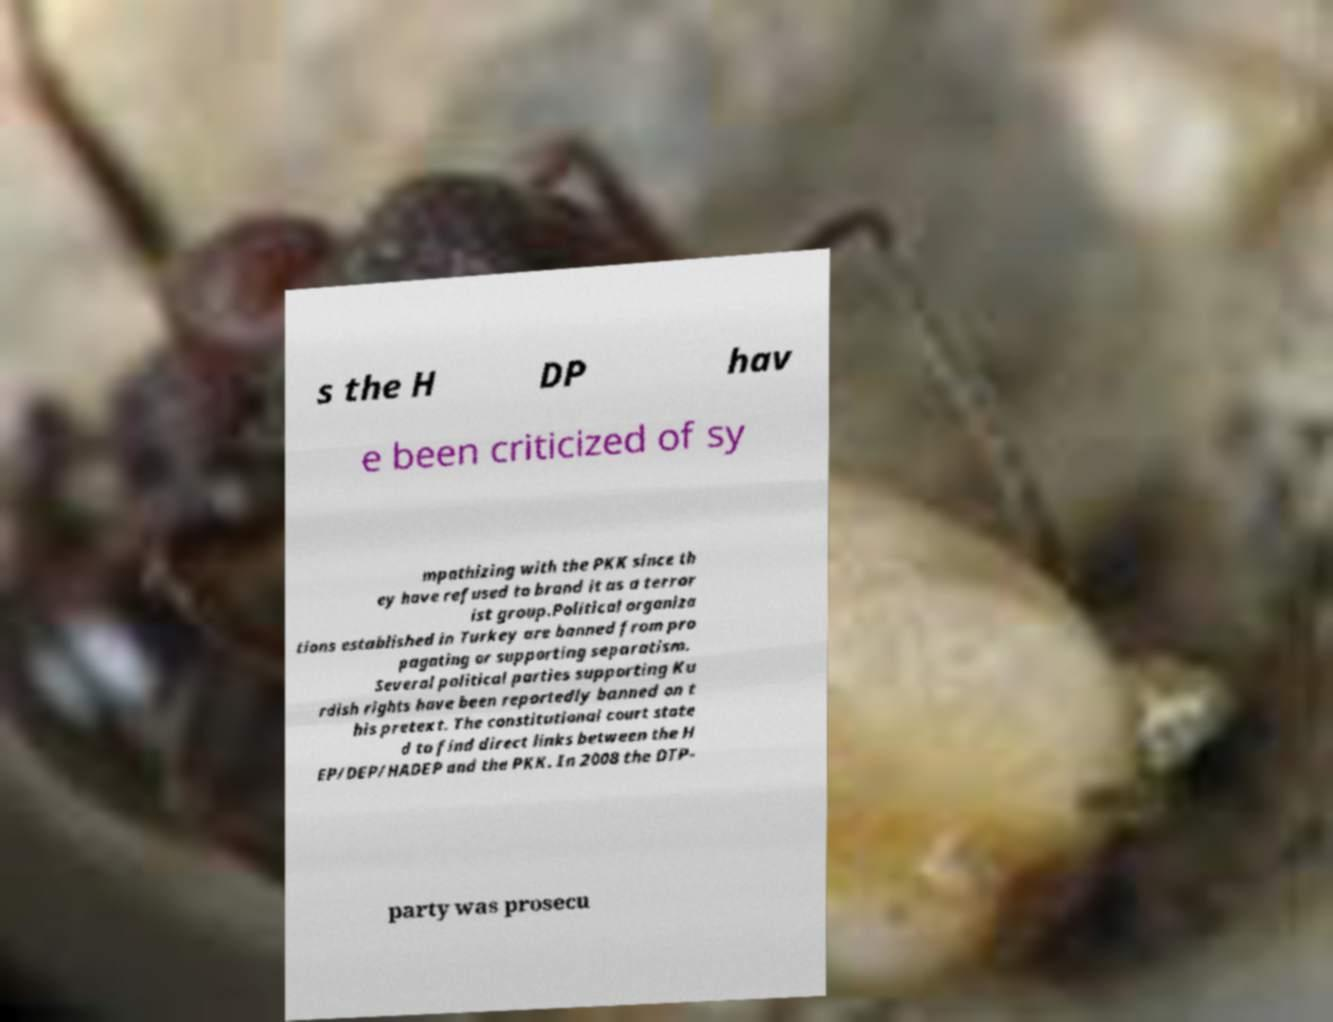Could you extract and type out the text from this image? s the H DP hav e been criticized of sy mpathizing with the PKK since th ey have refused to brand it as a terror ist group.Political organiza tions established in Turkey are banned from pro pagating or supporting separatism. Several political parties supporting Ku rdish rights have been reportedly banned on t his pretext. The constitutional court state d to find direct links between the H EP/DEP/HADEP and the PKK. In 2008 the DTP- party was prosecu 